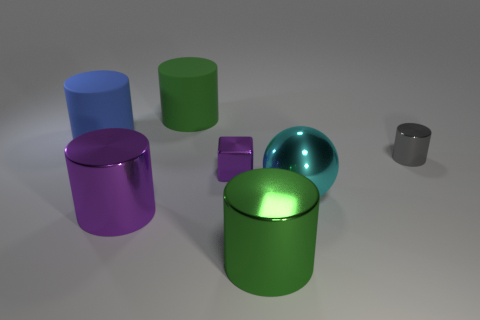Subtract all purple blocks. How many green cylinders are left? 2 Subtract all large blue rubber cylinders. How many cylinders are left? 4 Subtract 2 cylinders. How many cylinders are left? 3 Subtract all gray cylinders. How many cylinders are left? 4 Add 2 purple metal cubes. How many objects exist? 9 Subtract all blue cylinders. Subtract all purple balls. How many cylinders are left? 4 Subtract all cylinders. How many objects are left? 2 Subtract 0 red spheres. How many objects are left? 7 Subtract all large purple metal cylinders. Subtract all green rubber things. How many objects are left? 5 Add 3 small metal cubes. How many small metal cubes are left? 4 